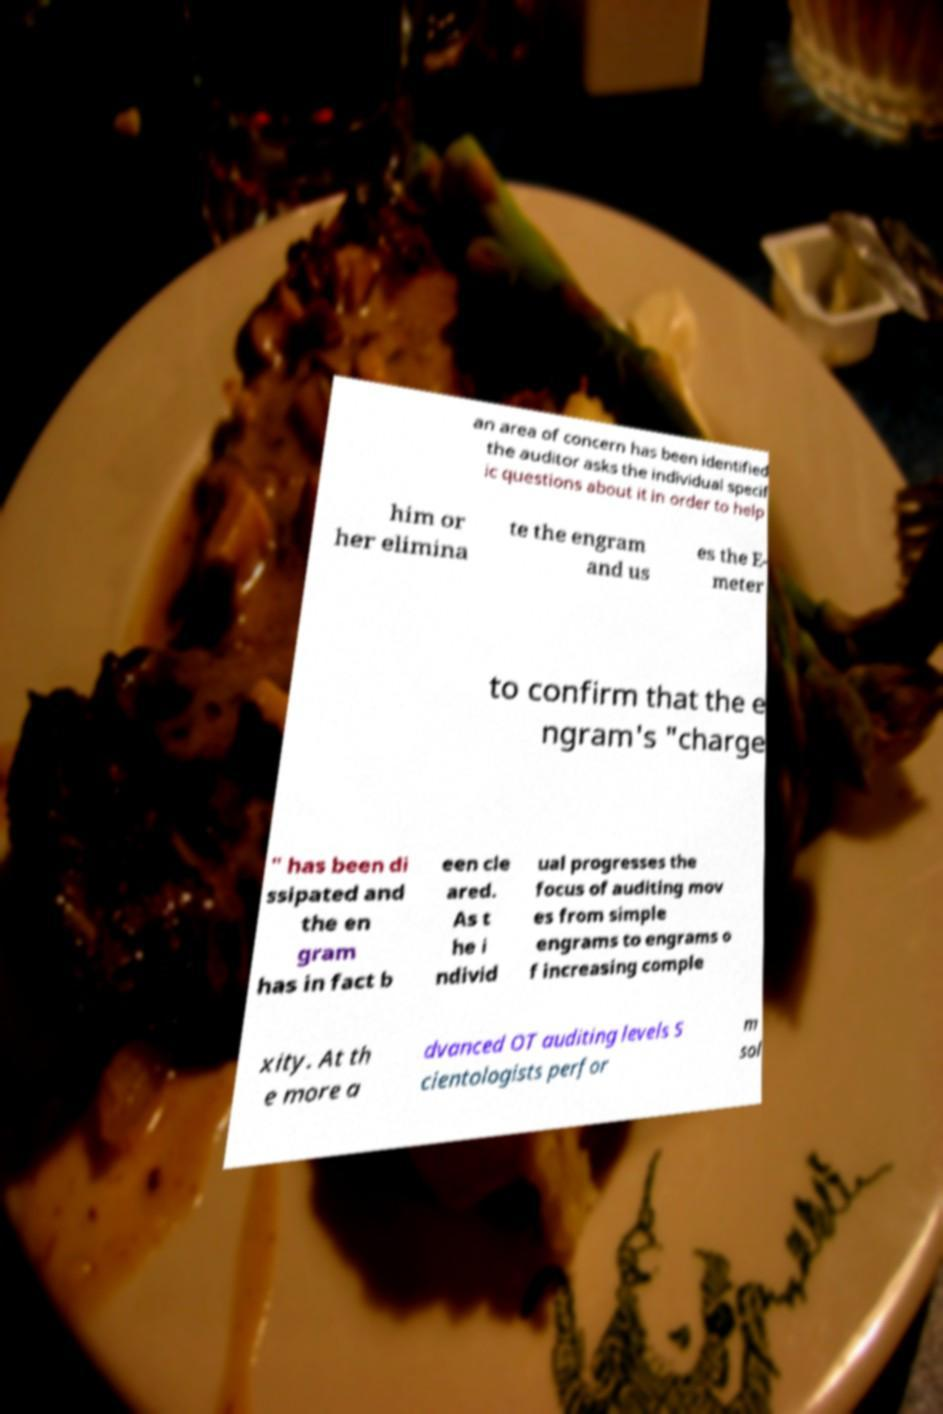Can you accurately transcribe the text from the provided image for me? an area of concern has been identified the auditor asks the individual specif ic questions about it in order to help him or her elimina te the engram and us es the E- meter to confirm that the e ngram's "charge " has been di ssipated and the en gram has in fact b een cle ared. As t he i ndivid ual progresses the focus of auditing mov es from simple engrams to engrams o f increasing comple xity. At th e more a dvanced OT auditing levels S cientologists perfor m sol 